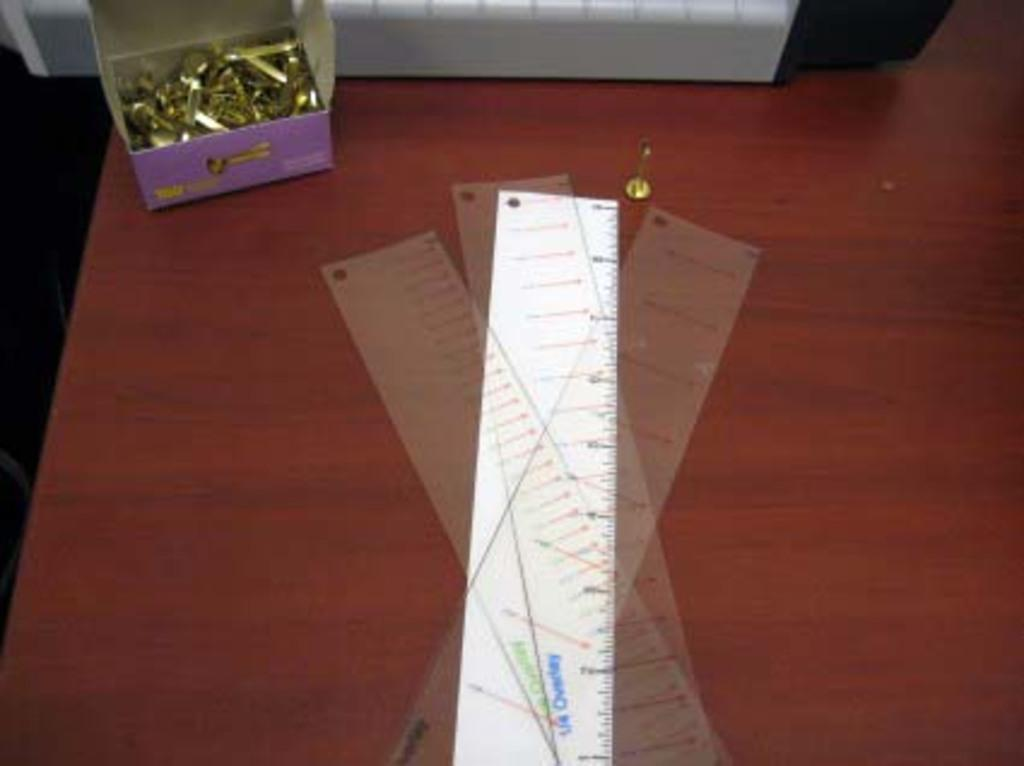What type of measuring instrument is visible in the image? There are scales in the image. What type of hardware can be seen in the image? There is a box with bolts in the image. What color combination is present in one of the objects in the image? There is an object in a white and black combination in the image. Where are these items placed in the image? All of these items are placed on a table. What type of chin is visible in the image? There is no chin present in the image. What type of stone can be seen in the image? There is no stone present in the image. 